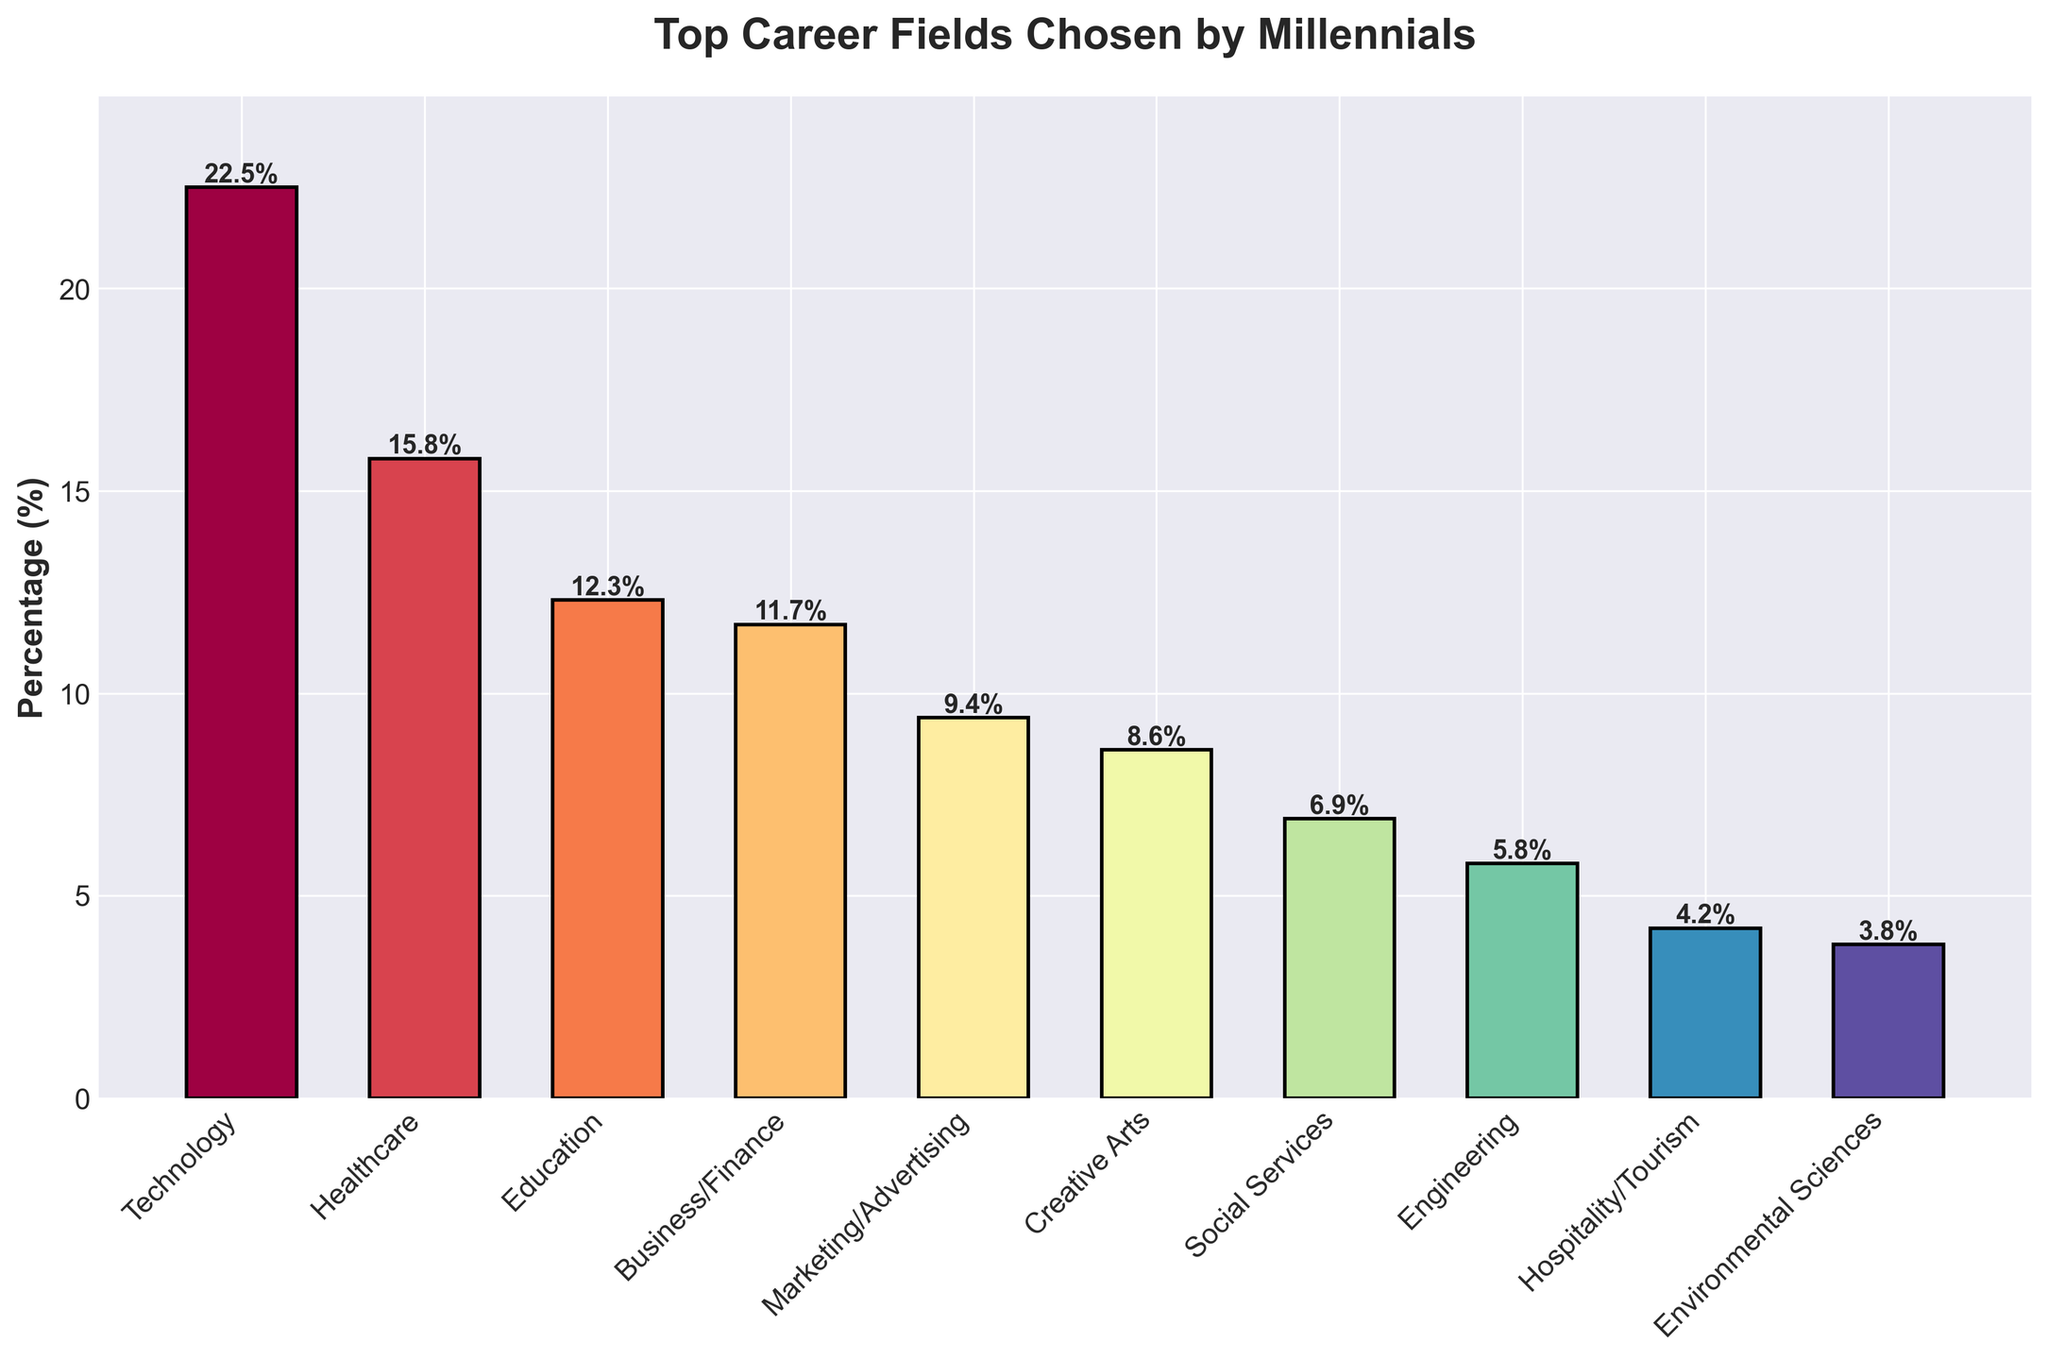What is the most popular career field among millennials according to the plot? The tallest bar in the plot represents the most popular career field, which is Technology with a percentage of 22.5%.
Answer: Technology Which career fields have percentages below 10%? We look at the bars with heights below the 10% mark. These fields are Marketing/Advertising (9.4%), Creative Arts (8.6%), Social Services (6.9%), Engineering (5.8%), Hospitality/Tourism (4.2%), and Environmental Sciences (3.8%).
Answer: Marketing/Advertising, Creative Arts, Social Services, Engineering, Hospitality/Tourism, Environmental Sciences How much higher is the percentage of the Technology field compared to the Engineering field? The percentage for Technology is 22.5% and for Engineering, it is 5.8%. The difference is calculated as 22.5% - 5.8% = 16.7%.
Answer: 16.7% What is the combined percentage of millennials in Healthcare and Education fields? The percentages for Healthcare and Education are 15.8% and 12.3%, respectively. The sum is 15.8% + 12.3% = 28.1%.
Answer: 28.1% Which career field has the least number of millennials, and what is its percentage? The shortest bar in the plot represents the least popular field, which is Environmental Sciences with a percentage of 3.8%.
Answer: Environmental Sciences, 3.8% Compare the popularity of the Business/Finance field with the Creative Arts field. Which one has a higher percentage and by how much? The percentage for Business/Finance is 11.7% and for Creative Arts, it is 8.6%. Business/Finance has a higher percentage by 11.7% - 8.6% = 3.1%.
Answer: Business/Finance, 3.1% What is the average percentage of millennials in Technology, Healthcare, and Education fields? The percentages are Technology (22.5%), Healthcare (15.8%), and Education (12.3%). The sum is 22.5 + 15.8 + 12.3 = 50.6. Dividing by 3 gives an average of 50.6 / 3 ≈ 16.87%.
Answer: 16.87% If you combine the percentages of all fields with a percentage lower than 10%, what is the total combined percentage? Adding the percentages of Marketing/Advertising (9.4%), Creative Arts (8.6%), Social Services (6.9%), Engineering (5.8%), Hospitality/Tourism (4.2%), and Environmental Sciences (3.8%) gives 9.4 + 8.6 + 6.9 + 5.8 + 4.2 + 3.8 = 38.7%.
Answer: 38.7% 